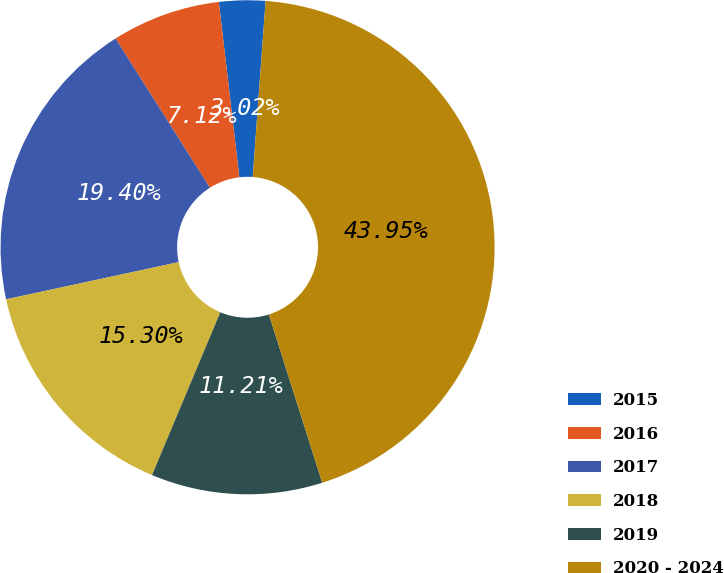Convert chart. <chart><loc_0><loc_0><loc_500><loc_500><pie_chart><fcel>2015<fcel>2016<fcel>2017<fcel>2018<fcel>2019<fcel>2020 - 2024<nl><fcel>3.02%<fcel>7.12%<fcel>19.4%<fcel>15.3%<fcel>11.21%<fcel>43.95%<nl></chart> 